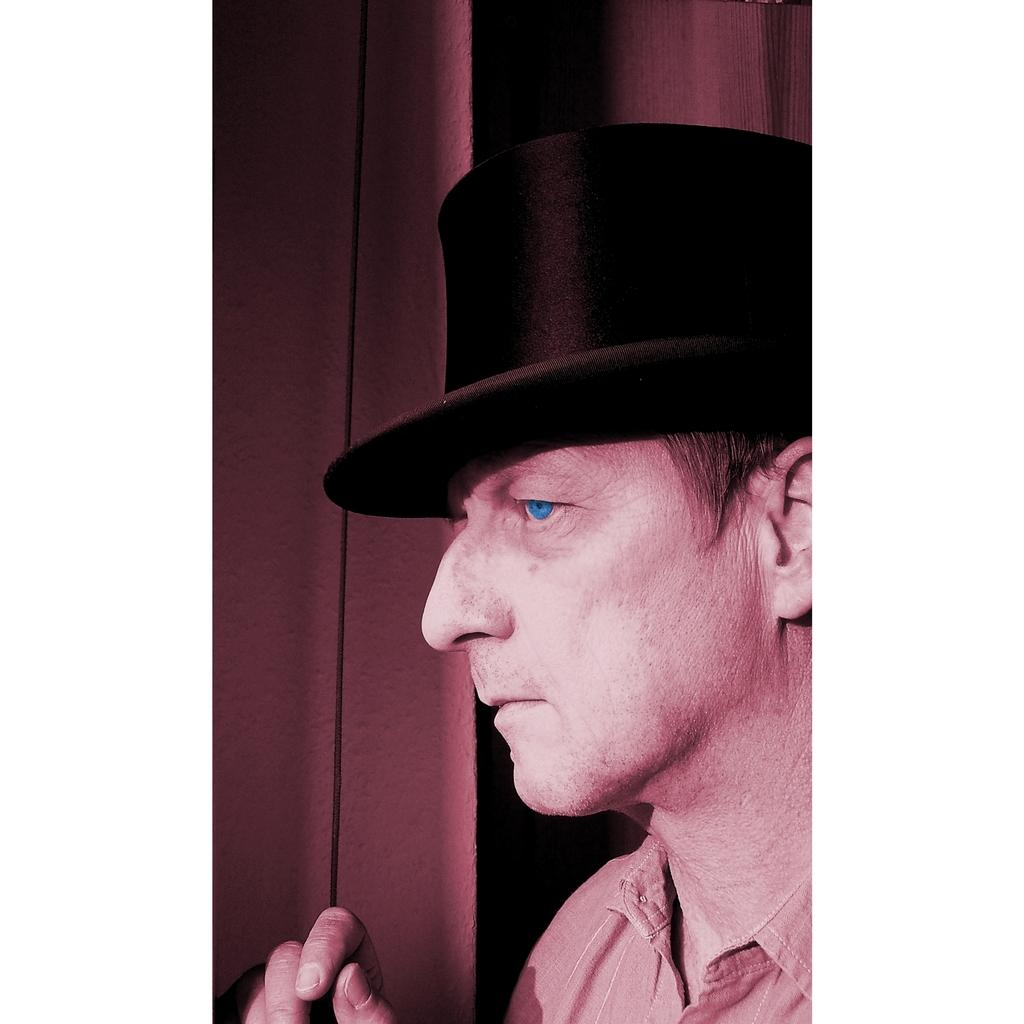What is the main subject of the image? There is a man in the image. What is the man wearing on his head? The man is wearing a hat. What type of clothing is the man wearing on his upper body? The man is wearing a shirt. What color is the crayon the man is holding in the image? There is no crayon present in the image. How many hands does the man have in the image? The image does not show the man's hands, so it is impossible to determine the number of hands he has. 